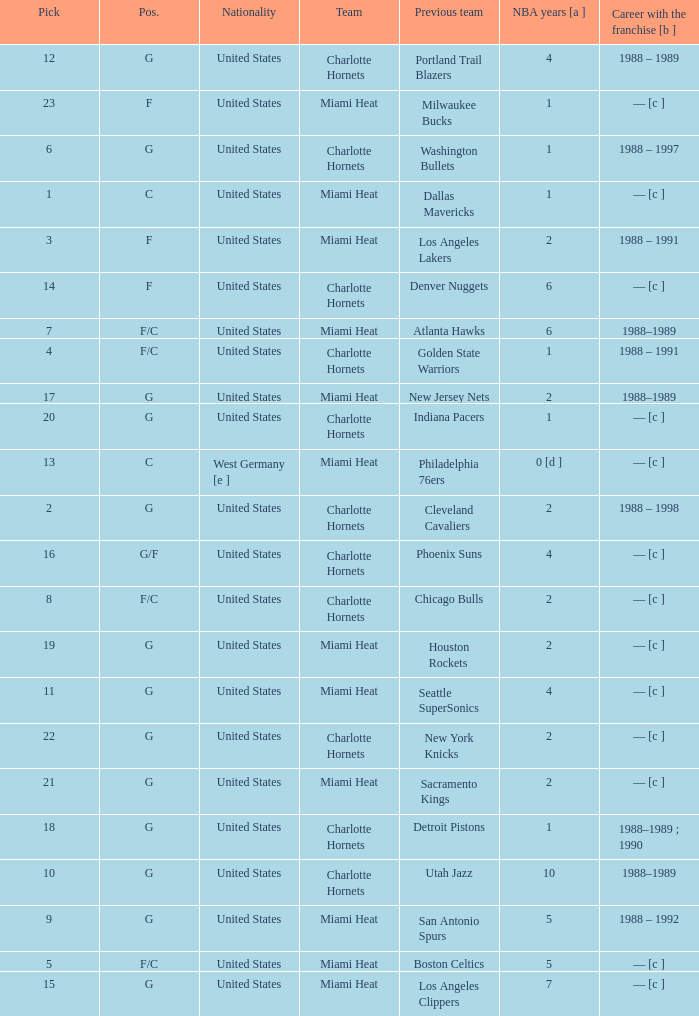How many NBA years did the player from the United States who was previously on the los angeles lakers have? 2.0. 